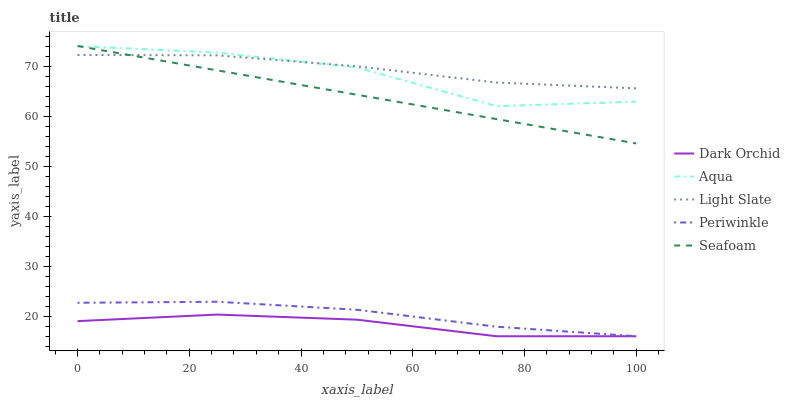Does Dark Orchid have the minimum area under the curve?
Answer yes or no. Yes. Does Light Slate have the maximum area under the curve?
Answer yes or no. Yes. Does Periwinkle have the minimum area under the curve?
Answer yes or no. No. Does Periwinkle have the maximum area under the curve?
Answer yes or no. No. Is Seafoam the smoothest?
Answer yes or no. Yes. Is Aqua the roughest?
Answer yes or no. Yes. Is Periwinkle the smoothest?
Answer yes or no. No. Is Periwinkle the roughest?
Answer yes or no. No. Does Aqua have the lowest value?
Answer yes or no. No. Does Periwinkle have the highest value?
Answer yes or no. No. Is Periwinkle less than Aqua?
Answer yes or no. Yes. Is Aqua greater than Periwinkle?
Answer yes or no. Yes. Does Periwinkle intersect Aqua?
Answer yes or no. No. 